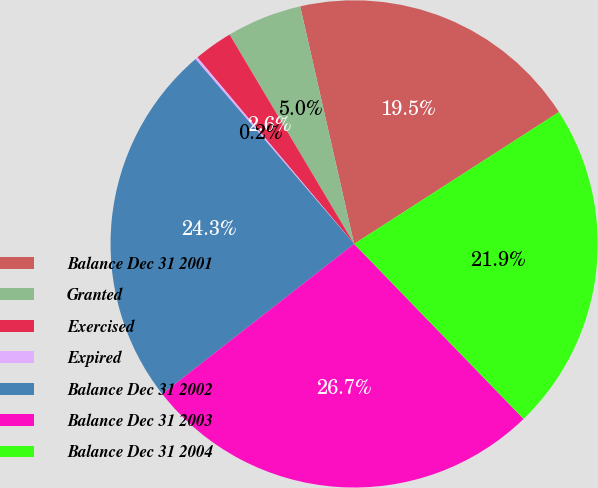<chart> <loc_0><loc_0><loc_500><loc_500><pie_chart><fcel>Balance Dec 31 2001<fcel>Granted<fcel>Exercised<fcel>Expired<fcel>Balance Dec 31 2002<fcel>Balance Dec 31 2003<fcel>Balance Dec 31 2004<nl><fcel>19.45%<fcel>4.99%<fcel>2.58%<fcel>0.17%<fcel>24.27%<fcel>26.68%<fcel>21.86%<nl></chart> 